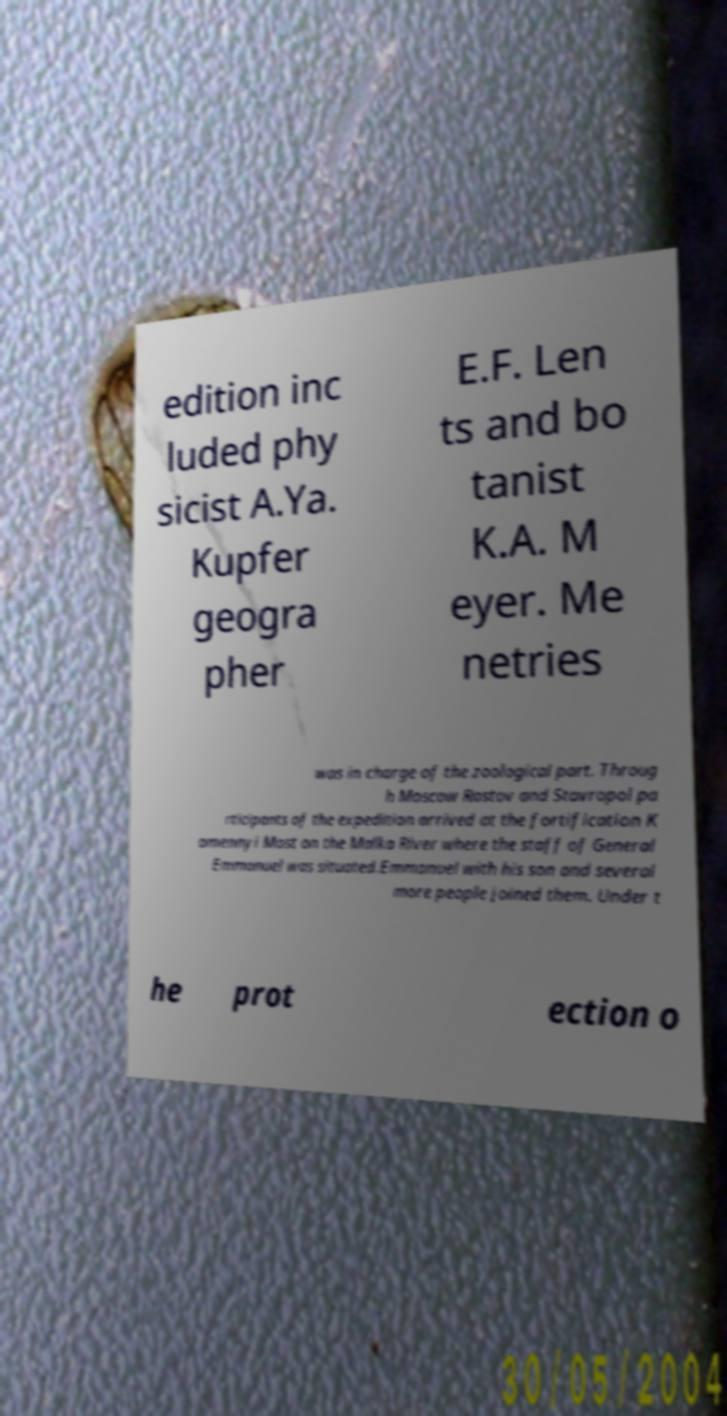There's text embedded in this image that I need extracted. Can you transcribe it verbatim? edition inc luded phy sicist A.Ya. Kupfer geogra pher E.F. Len ts and bo tanist K.A. M eyer. Me netries was in charge of the zoological part. Throug h Moscow Rostov and Stavropol pa rticipants of the expedition arrived at the fortification K amennyi Most on the Malka River where the staff of General Emmanuel was situated.Emmanuel with his son and several more people joined them. Under t he prot ection o 